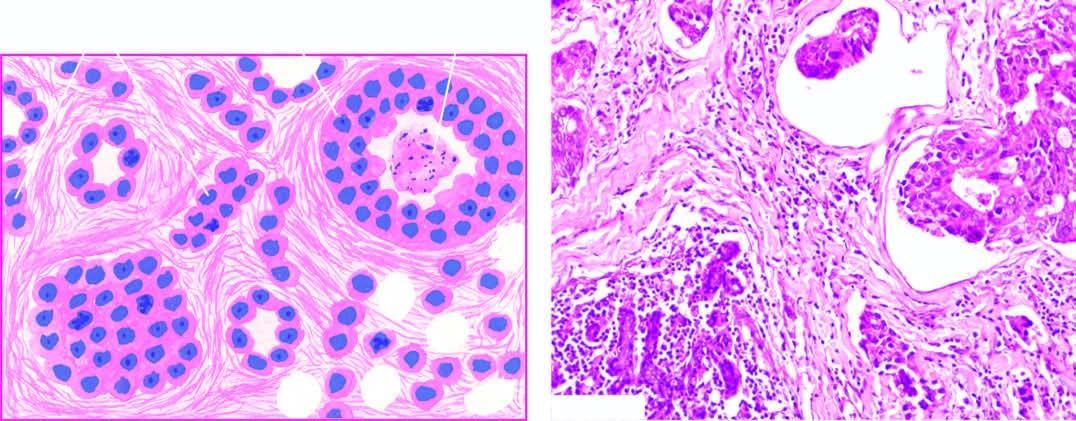s there infiltration of densely collagenised stroma by these cells in a haphazard manner?
Answer the question using a single word or phrase. Yes 